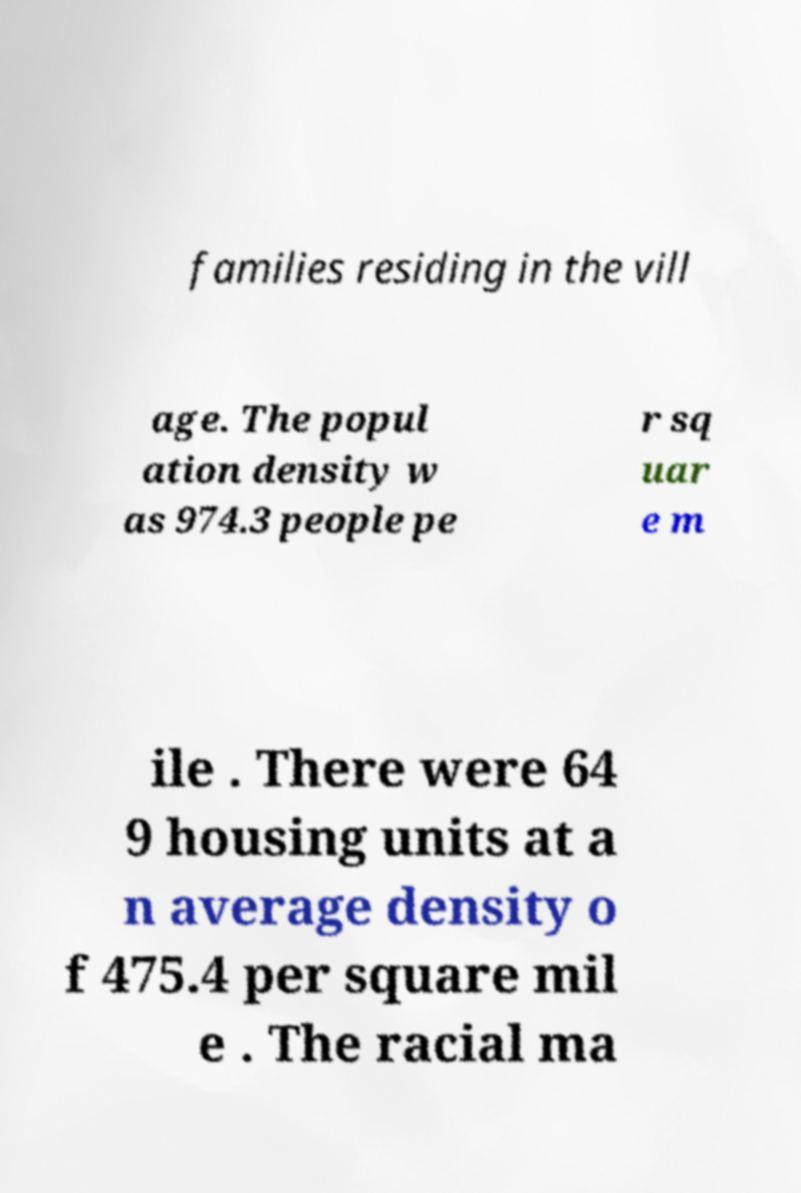Could you assist in decoding the text presented in this image and type it out clearly? families residing in the vill age. The popul ation density w as 974.3 people pe r sq uar e m ile . There were 64 9 housing units at a n average density o f 475.4 per square mil e . The racial ma 